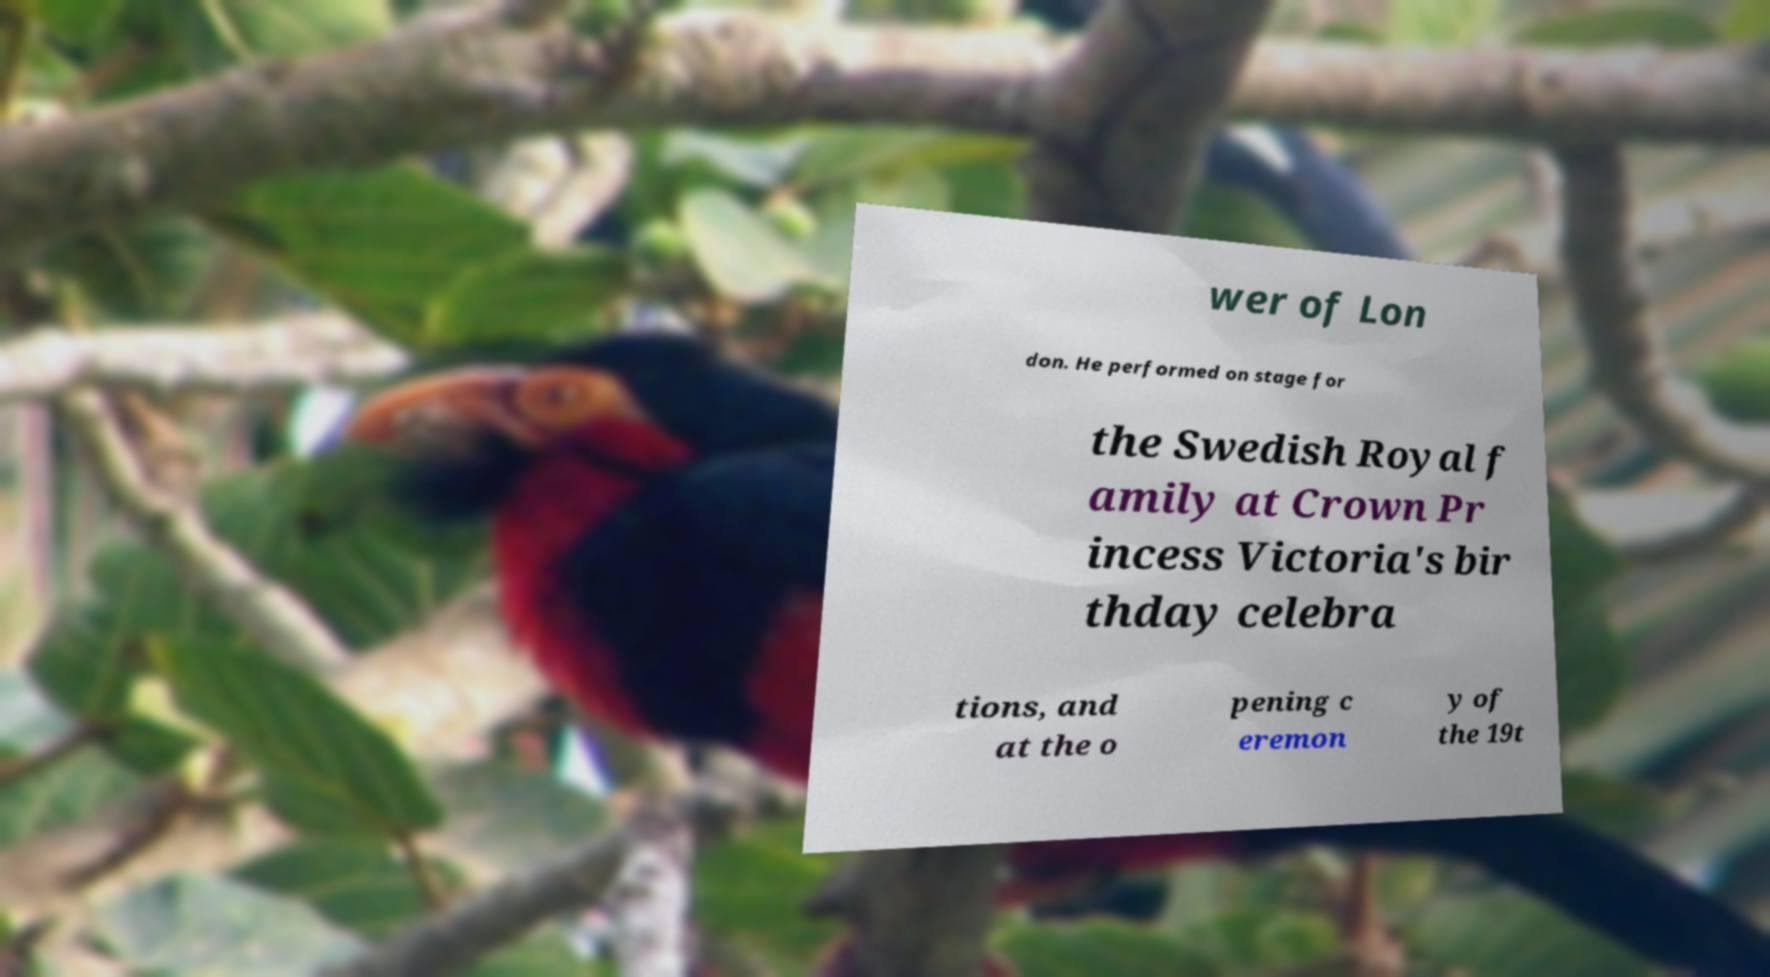Please read and relay the text visible in this image. What does it say? wer of Lon don. He performed on stage for the Swedish Royal f amily at Crown Pr incess Victoria's bir thday celebra tions, and at the o pening c eremon y of the 19t 